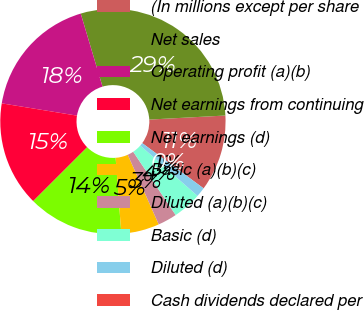<chart> <loc_0><loc_0><loc_500><loc_500><pie_chart><fcel>(In millions except per share<fcel>Net sales<fcel>Operating profit (a)(b)<fcel>Net earnings from continuing<fcel>Net earnings (d)<fcel>Basic (a)(b)(c)<fcel>Diluted (a)(b)(c)<fcel>Basic (d)<fcel>Diluted (d)<fcel>Cash dividends declared per<nl><fcel>10.96%<fcel>28.77%<fcel>17.81%<fcel>15.07%<fcel>13.7%<fcel>5.48%<fcel>2.74%<fcel>4.11%<fcel>1.37%<fcel>0.0%<nl></chart> 